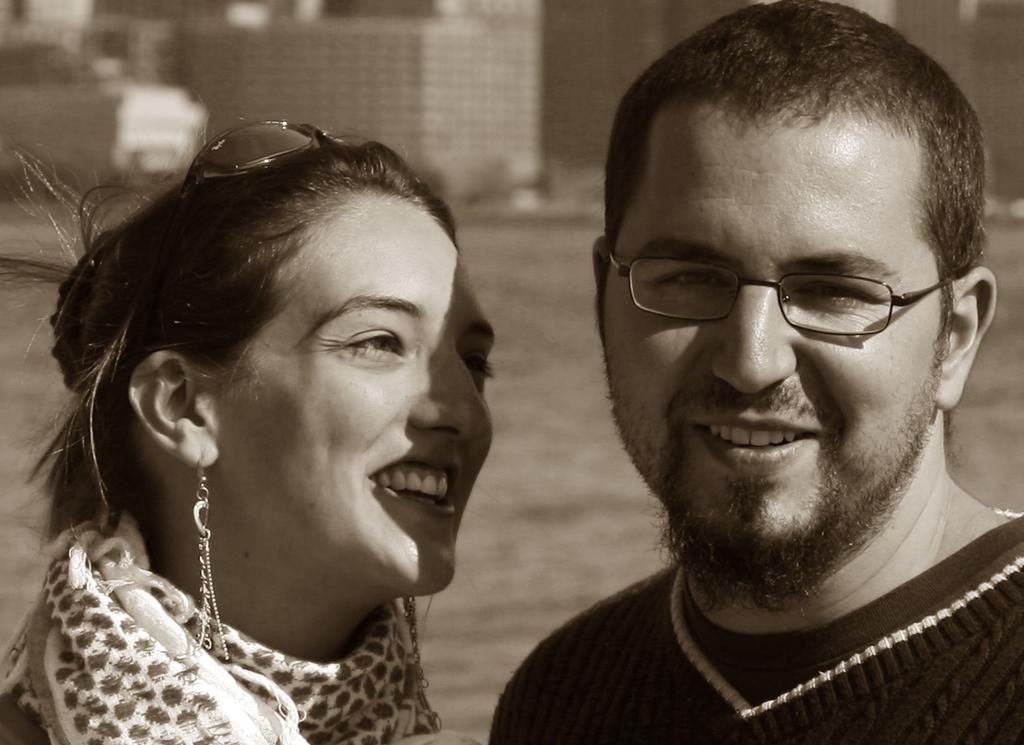How many people are in the image? There are two persons in the image. What is the facial expression of the persons in the image? The persons are smiling. What can be seen in the background of the image? There are buildings in the background of the image. What is the chance of the persons in the image winning a lottery? There is no information about a lottery or any chance of winning in the image. 